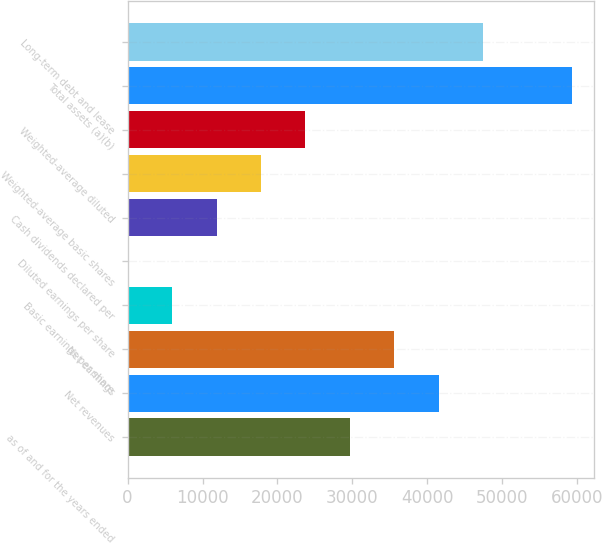<chart> <loc_0><loc_0><loc_500><loc_500><bar_chart><fcel>as of and for the years ended<fcel>Net revenues<fcel>Net earnings<fcel>Basic earnings per share<fcel>Diluted earnings per share<fcel>Cash dividends declared per<fcel>Weighted-average basic shares<fcel>Weighted-average diluted<fcel>Total assets (a)(b)<fcel>Long-term debt and lease<nl><fcel>29677.8<fcel>41547.5<fcel>35612.6<fcel>5938.49<fcel>3.66<fcel>11873.3<fcel>17808.2<fcel>23743<fcel>59352<fcel>47482.3<nl></chart> 